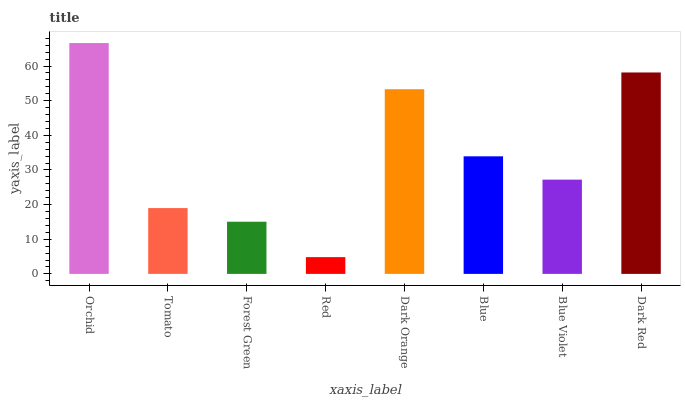Is Red the minimum?
Answer yes or no. Yes. Is Orchid the maximum?
Answer yes or no. Yes. Is Tomato the minimum?
Answer yes or no. No. Is Tomato the maximum?
Answer yes or no. No. Is Orchid greater than Tomato?
Answer yes or no. Yes. Is Tomato less than Orchid?
Answer yes or no. Yes. Is Tomato greater than Orchid?
Answer yes or no. No. Is Orchid less than Tomato?
Answer yes or no. No. Is Blue the high median?
Answer yes or no. Yes. Is Blue Violet the low median?
Answer yes or no. Yes. Is Red the high median?
Answer yes or no. No. Is Red the low median?
Answer yes or no. No. 